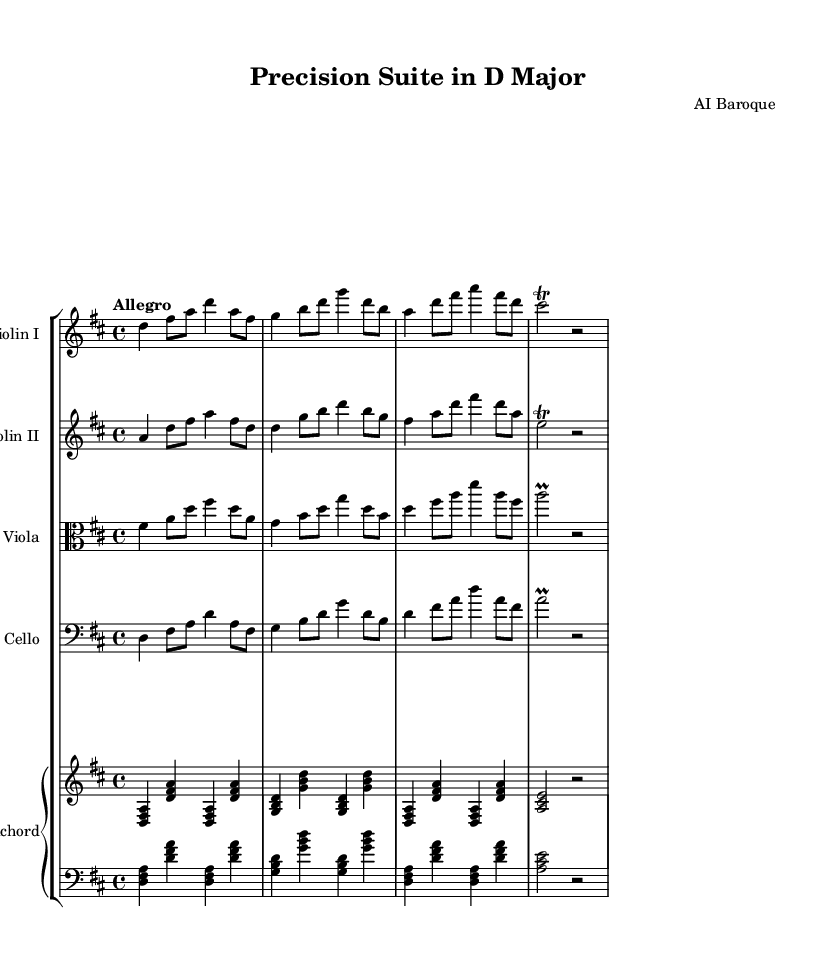What is the key signature of this music? The key signature is D major, which has two sharps (F# and C#). This can be identified at the beginning of the score, where the key signature is indicated.
Answer: D major What is the time signature of this music? The time signature is 4/4, which can be seen at the beginning of the score right after the key signature. This means there are four beats in each measure, and the quarter note gets one beat.
Answer: 4/4 What is the tempo marking for this piece? The tempo marking is "Allegro," which indicates a fast tempo. It is located at the beginning of the score, in the global music settings.
Answer: Allegro How many beats does the first measure contain? The first measure contains four beats, which aligns with the time signature of 4/4. Each quarter note and eighth note in this measure sums up to four beats.
Answer: 4 beats What instrument is indicated for the bass clef staff? The instrument indicated for the bass clef staff is Cello, which is specified at the beginning of that staff in the score.
Answer: Cello Which instruments are part of the orchestral suite? The instruments in the orchestral suite are Violin I, Violin II, Viola, Cello, and Harpsichord. This can be identified in the staff group section of the score where each instrument is labeled.
Answer: Violin I, Violin II, Viola, Cello, Harpsichord What type of ornamentation is used in the cello part? The ornamentation used in the cello part is a "prall," which is a type of grace note indicated at the end of the phrase in the score.
Answer: Prall 